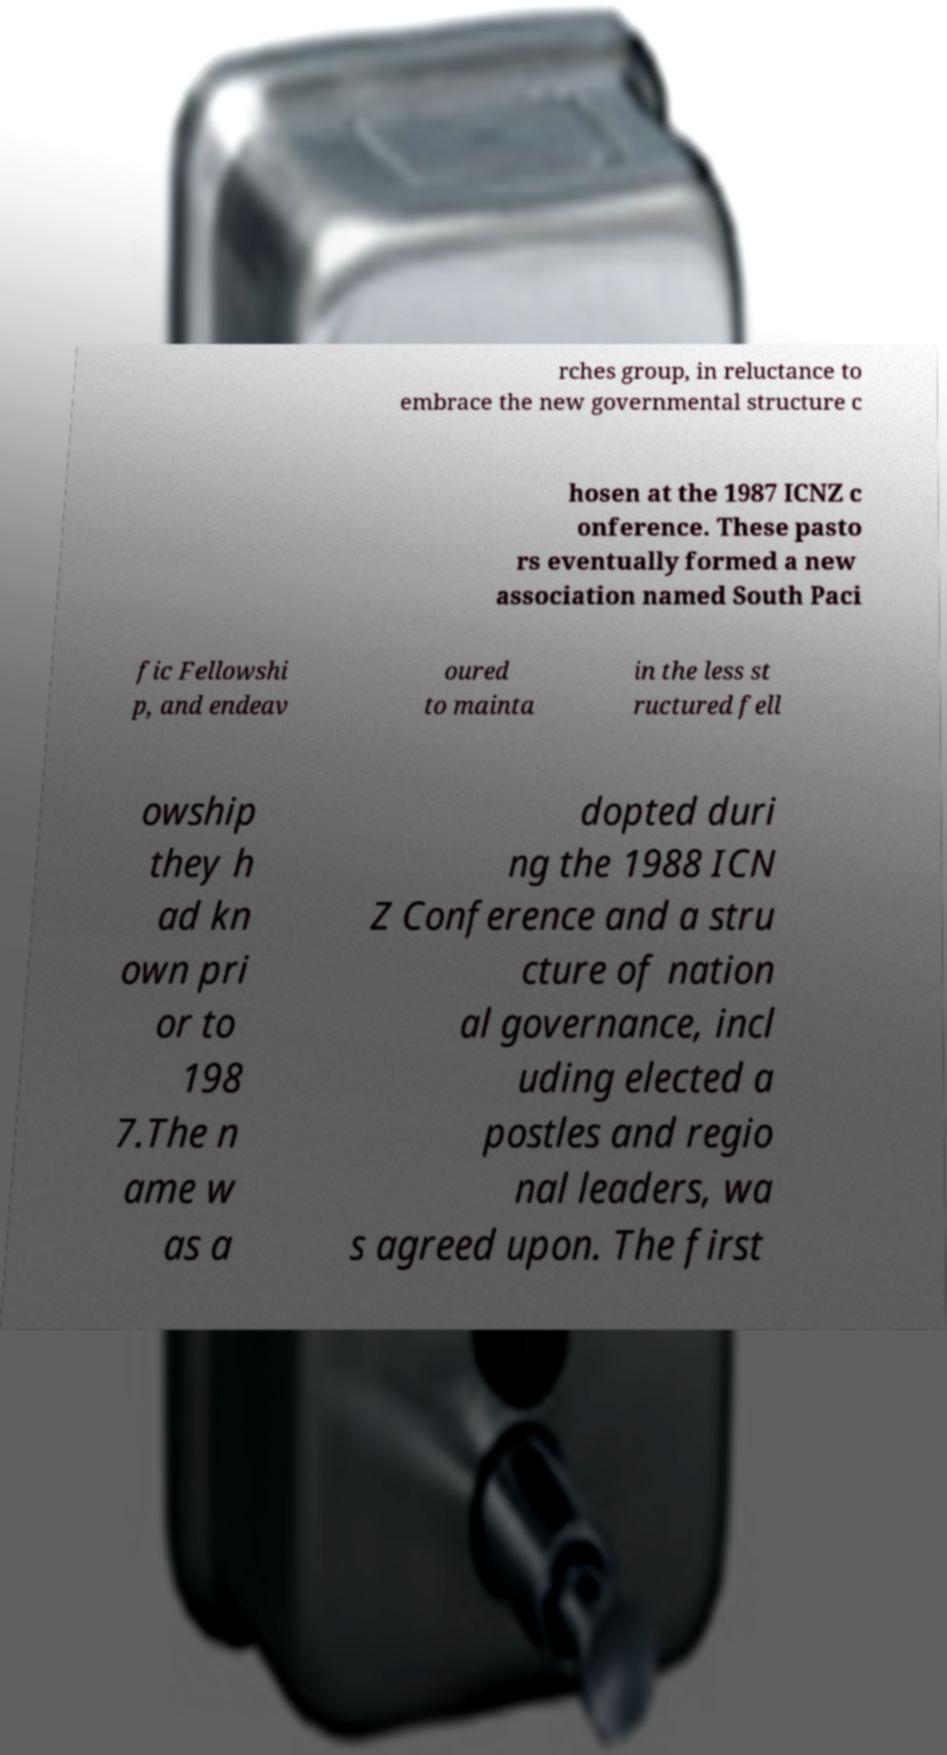Could you extract and type out the text from this image? rches group, in reluctance to embrace the new governmental structure c hosen at the 1987 ICNZ c onference. These pasto rs eventually formed a new association named South Paci fic Fellowshi p, and endeav oured to mainta in the less st ructured fell owship they h ad kn own pri or to 198 7.The n ame w as a dopted duri ng the 1988 ICN Z Conference and a stru cture of nation al governance, incl uding elected a postles and regio nal leaders, wa s agreed upon. The first 